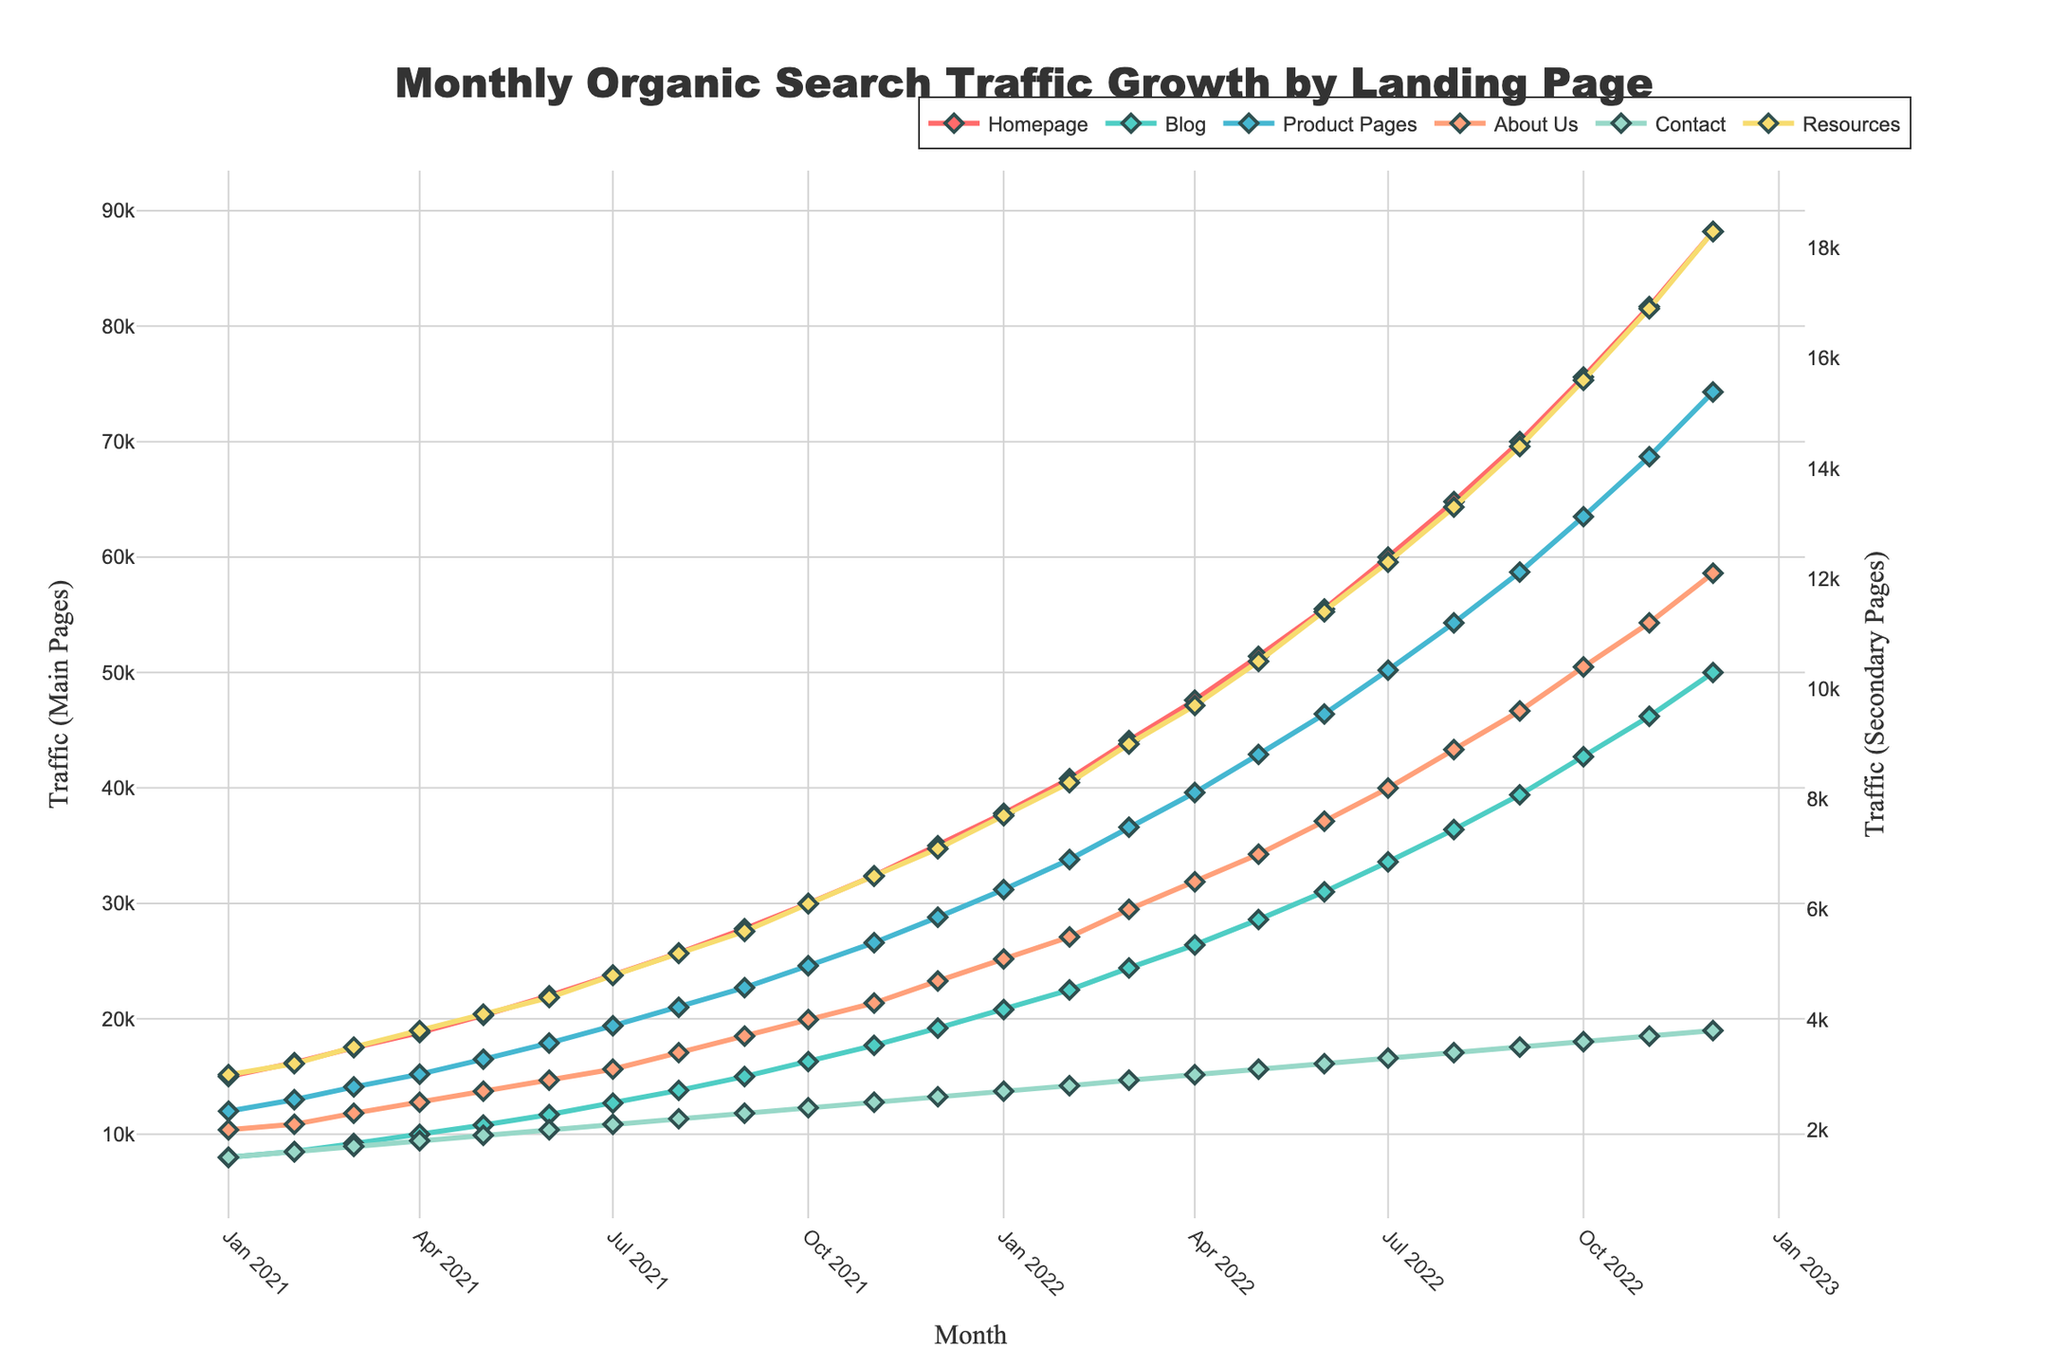What is the overall trend in organic search traffic for the Homepage over the two years? To determine the overall trend, we look at the data points for the Homepage monthly organic search traffic from Jan 2021 to Dec 2022. The curve visually shows a continuous rise from 15,000 to 88,200, indicating a steady upward trend.
Answer: Steadily increasing Which landing page experienced the highest traffic growth by the end of the period? To find the landing page with the highest traffic growth, we compare the Dec 2022 values for all landing pages. The Homepage shows the highest value at 88,200.
Answer: Homepage How did the Blog page's traffic change from Jan 2021 to Dec 2022? From Jan 2021, the Blog page’s traffic was 8,000. By Dec 2022, it had grown to 50,000. This indicates a significant increase over the two years.
Answer: Increased significantly Compare the traffic trends for the Product Pages and Resources page. To compare, evaluate both lines from the beginning to the end of the period. The Product Pages start at 12,000 and end at 74,300, while Resources start at 3,000 and end at 18,300. Both show upward trends, but Product Pages increased more sharply.
Answer: Product Pages increased more sharply Which month shows the highest traffic for the Contact page, and what is the value? Examine the line for the Contact page and identify the peak point. The highest traffic is seen in Dec 2022, with a value of 3,800.
Answer: Dec 2022, 3,800 Calculate the average monthly growth in traffic for the About Us page over the two years. The initial traffic in Jan 2021 is 2,000, and by Dec 2022, it is 12,100. The total increase is 12,100 - 2,000 = 10,100. Dividing by the 24 months results in an average monthly growth of 10,100 / 24 ≈ 421.
Answer: 421 Which months had the most significant increase in traffic for the Resources page, and by how much? The most significant increase is visible where the line ascends steeply. Between Nov 2022 and Dec 2022, the Resources page's traffic went from 16,900 to 18,300, a rise of 1,400.
Answer: Nov 2022 to Dec 2022, 1,400 What is the difference in traffic between the Homepage and Product Pages in Dec 2022? Subtract the Dec 2022 value of Product Pages (74,300) from the Homepage (88,200), which gives 88,200 - 74,300 = 13,900.
Answer: 13,900 Compare the traffic growth percentage for the Blog and About Us pages from Jan 2021 to Dec 2021. Blog from Jan 2021 (8,000) to Dec 2021 (19,200) has growth: (19,200-8,000)/8,000 ≈ 0.4 or 140%. About Us from Jan 2021 (2,000) to Dec 2021 (4,700) has growth: (4,700-2,000)/2,000 ≈ 1.35 or 135%.
Answer: Blog 140%, About Us 135% 